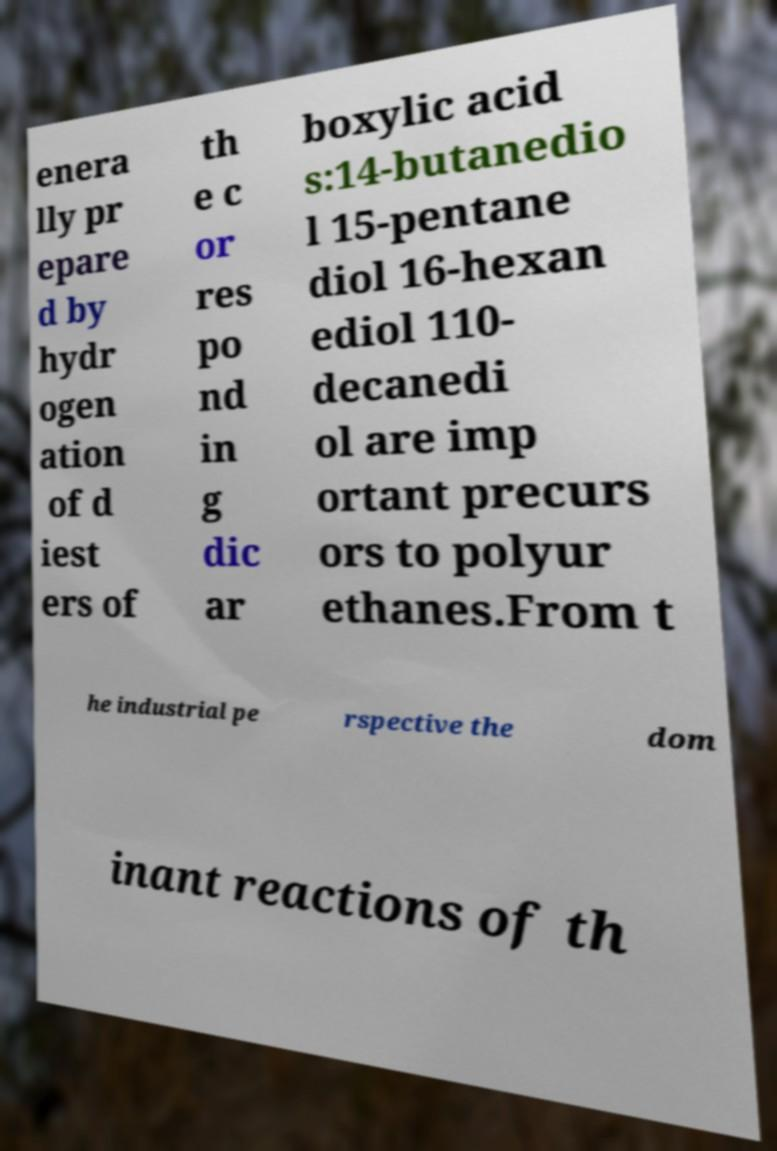Please identify and transcribe the text found in this image. enera lly pr epare d by hydr ogen ation of d iest ers of th e c or res po nd in g dic ar boxylic acid s:14-butanedio l 15-pentane diol 16-hexan ediol 110- decanedi ol are imp ortant precurs ors to polyur ethanes.From t he industrial pe rspective the dom inant reactions of th 